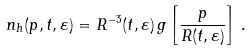Convert formula to latex. <formula><loc_0><loc_0><loc_500><loc_500>n _ { h } ( p , t , \varepsilon ) = R ^ { - 3 } ( t , \varepsilon ) \, g \left [ \frac { p } { R ( t , \varepsilon ) } \right ] \, .</formula> 